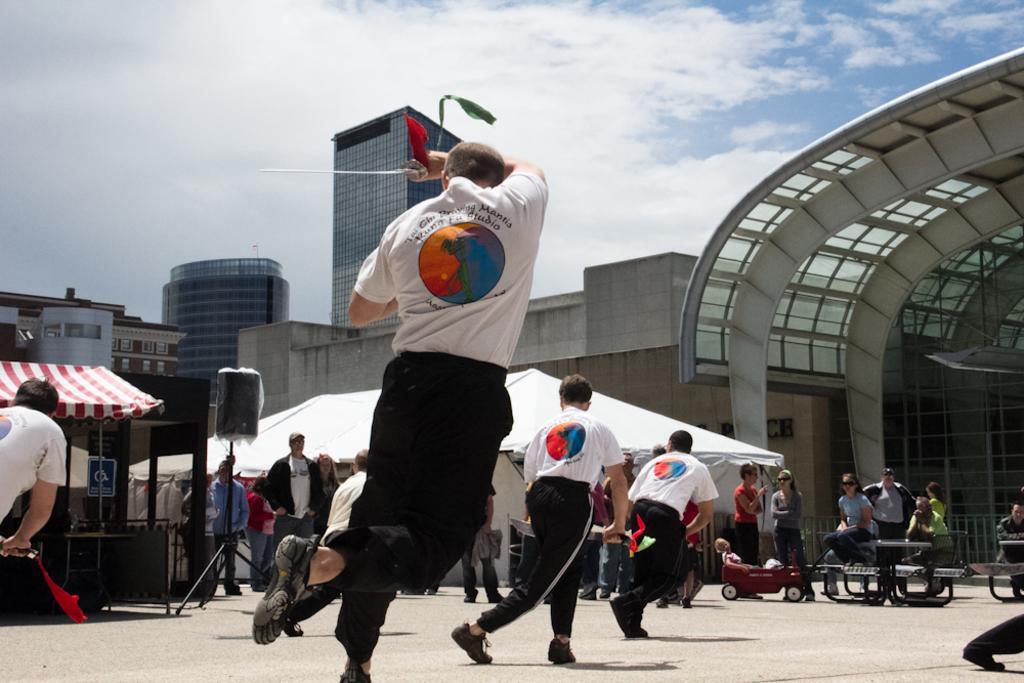How would you summarize this image in a sentence or two? In this picture I can see group of people standing and holding swords, there are group of people standing, there is a speaker with a stand, there are buildings, and in the background there is sky. 